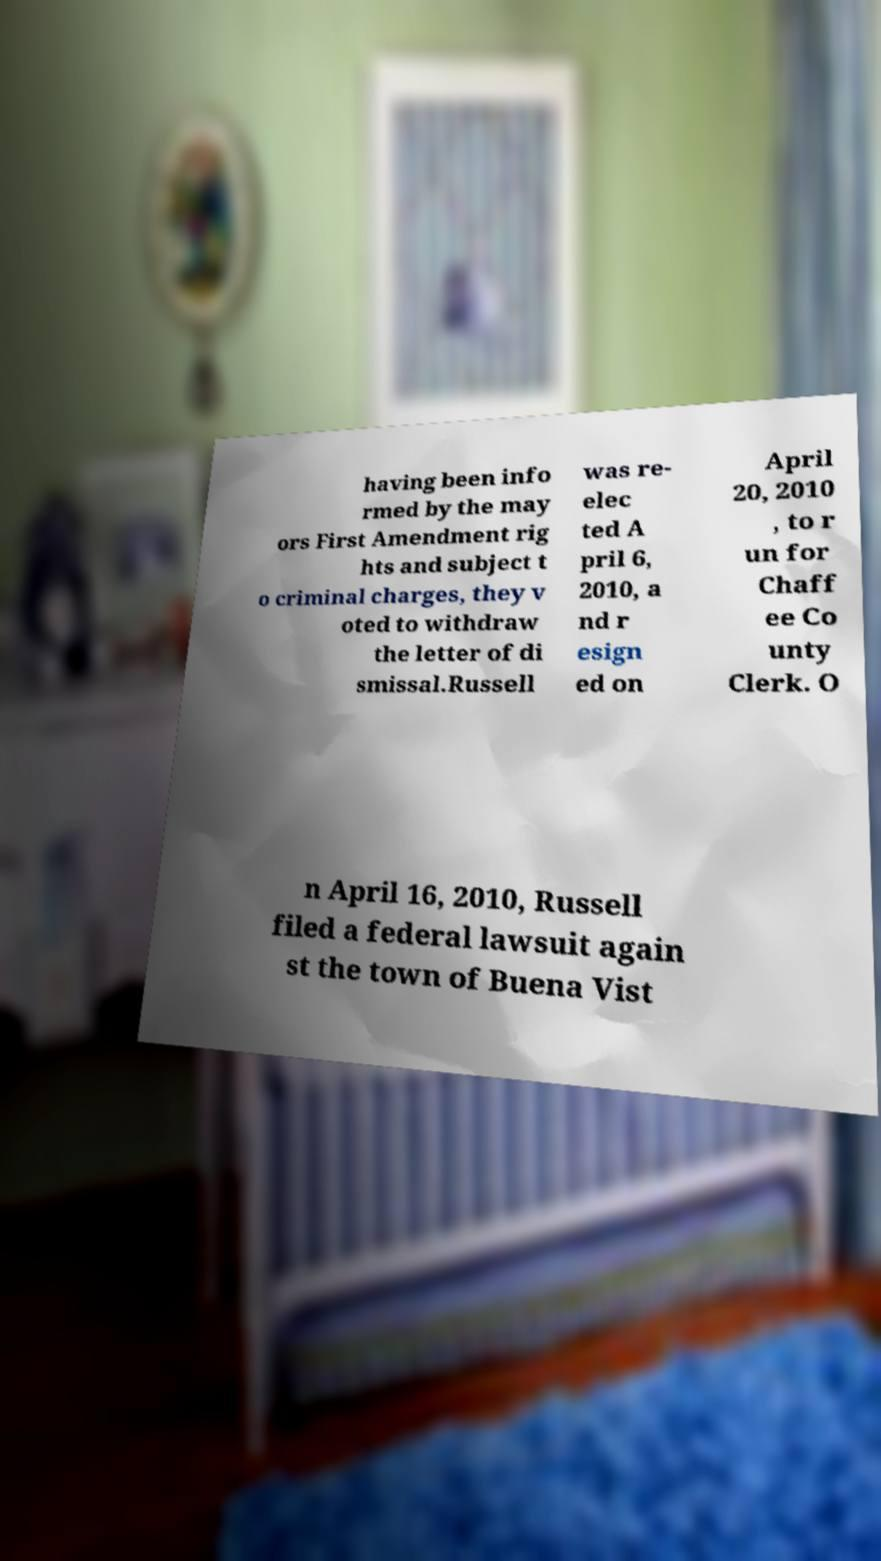What messages or text are displayed in this image? I need them in a readable, typed format. having been info rmed by the may ors First Amendment rig hts and subject t o criminal charges, they v oted to withdraw the letter of di smissal.Russell was re- elec ted A pril 6, 2010, a nd r esign ed on April 20, 2010 , to r un for Chaff ee Co unty Clerk. O n April 16, 2010, Russell filed a federal lawsuit again st the town of Buena Vist 